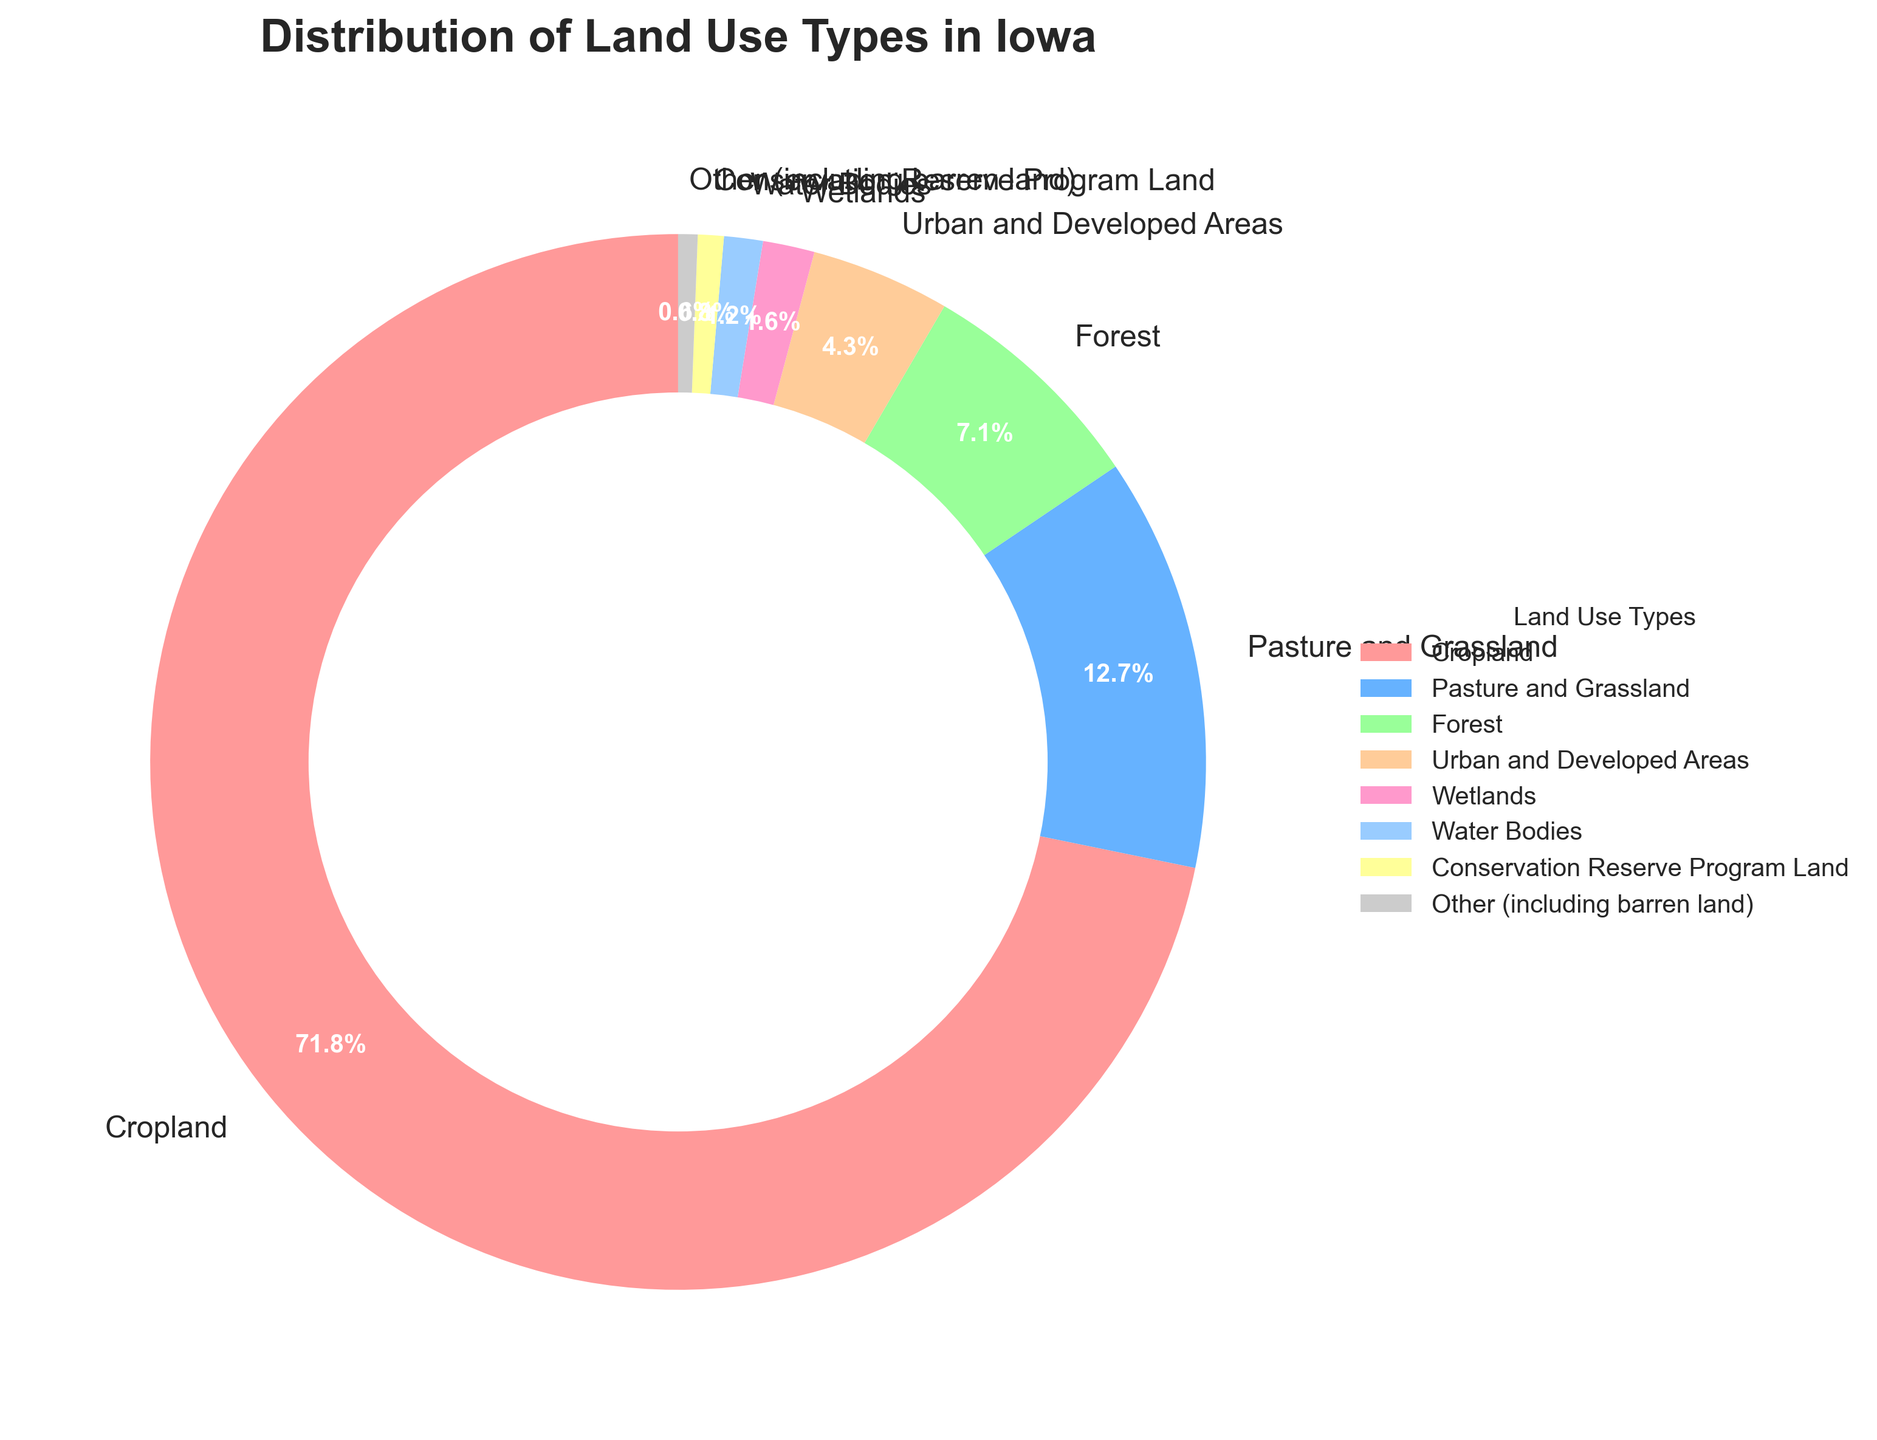What is the combined percentage of land used for Cropland and Pasture and Grassland? The pie chart shows that Cropland occupies 72.5% and Pasture and Grassland occupies 12.8%. Adding these together, 72.5 + 12.8 equals 85.3%.
Answer: 85.3% Does Forest cover more land than Urban and Developed Areas? According to the pie chart, Forest covers 7.2% while Urban and Developed Areas cover 4.3%. Since 7.2 is greater than 4.3, Forest does cover more land.
Answer: Yes Which land use type occupies the smallest percentage of land in Iowa? Observing the pie chart, Conservation Reserve Program Land and Other (including barren land) occupy 0.8% and 0.6% respectively, with the latter being the smallest percentage.
Answer: Other (including barren land) By how much does Wetlands exceed Water Bodies in land use percentage? Wetlands occupy 1.6% of the land, whereas Water Bodies occupy 1.2%. Subtracting 1.2 from 1.6, we get 0.4%.
Answer: 0.4% What proportion of Iowa's land is used for Urban and Developed Areas compared to Cropland? The percentage of land used for Urban and Developed Areas is 4.3%, while Cropland is 72.5%. Dividing 4.3 by 72.5 and multiplying by 100 gives us approximately 5.93%.
Answer: 5.93% Which color represents the land use type with the second smallest area, and what is this land use type? According to the pie chart, Conservation Reserve Program Land occupies 0.8% and is the second smallest area. It is represented in the color close to the yellow shade.
Answer: Yellow, Conservation Reserve Program Land If Forest, Wetlands, and Water Bodies are combined, what is their total percentage of land use? Adding the percentages of Forest (7.2%), Wetlands (1.6%), and Water Bodies (1.2%), we get 7.2 + 1.6 + 1.2 equals 10%.
Answer: 10% Is the visually largest segment of the chart representing Cropland? The pie chart shows that Cropland occupies 72.5%, which is visibly the largest segment in the chart.
Answer: Yes How does the percentage of Pasture and Grassland compare to the combined percentage of Wetlands and Water Bodies? Pasture and Grassland occupy 12.8%, while the combined percentage of Wetlands (1.6%) and Water Bodies (1.2%) is 2.8%. Since 12.8 is much greater than 2.8, Pasture and Grassland is significantly higher.
Answer: Pasture and Grassland is greater What land use type is represented in a green-colored segment, and how much of Iowa's land does it occupy? The green-colored segment in the pie chart represents Forest, which occupies 7.2% of the land.
Answer: Forest, 7.2% 